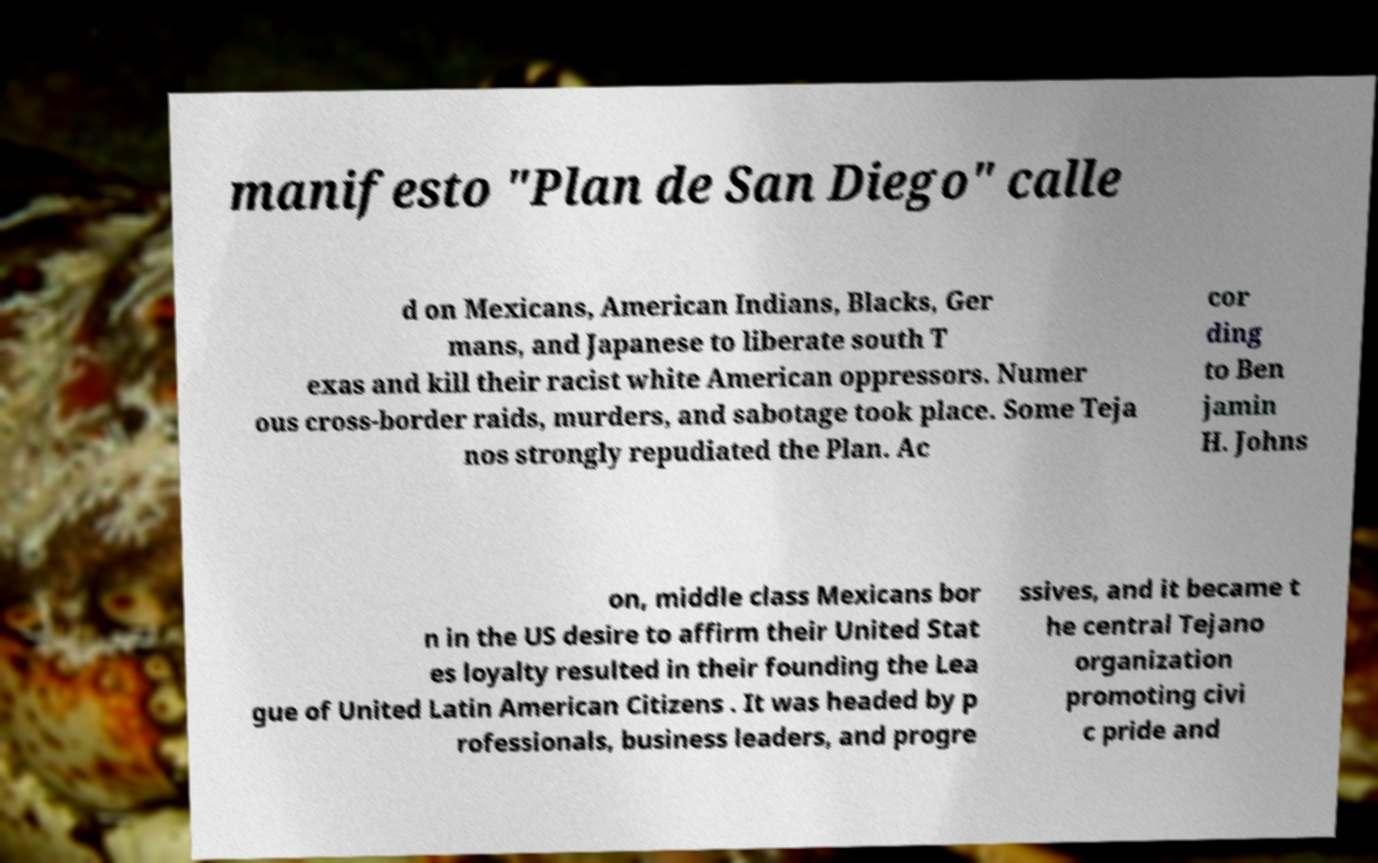Please identify and transcribe the text found in this image. manifesto "Plan de San Diego" calle d on Mexicans, American Indians, Blacks, Ger mans, and Japanese to liberate south T exas and kill their racist white American oppressors. Numer ous cross-border raids, murders, and sabotage took place. Some Teja nos strongly repudiated the Plan. Ac cor ding to Ben jamin H. Johns on, middle class Mexicans bor n in the US desire to affirm their United Stat es loyalty resulted in their founding the Lea gue of United Latin American Citizens . It was headed by p rofessionals, business leaders, and progre ssives, and it became t he central Tejano organization promoting civi c pride and 